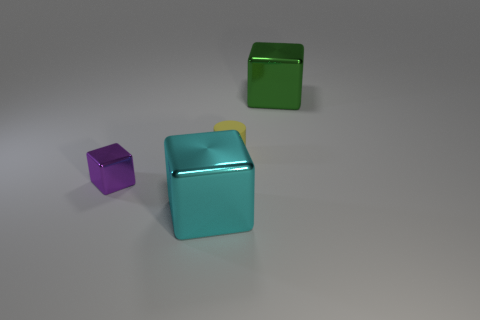Subtract 1 blocks. How many blocks are left? 2 Add 2 tiny red metallic objects. How many objects exist? 6 Subtract all cylinders. How many objects are left? 3 Add 3 yellow cylinders. How many yellow cylinders are left? 4 Add 4 small red rubber balls. How many small red rubber balls exist? 4 Subtract 0 brown cylinders. How many objects are left? 4 Subtract all yellow metallic spheres. Subtract all green shiny cubes. How many objects are left? 3 